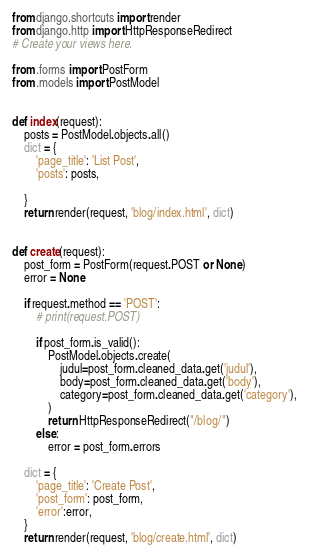<code> <loc_0><loc_0><loc_500><loc_500><_Python_>from django.shortcuts import render
from django.http import HttpResponseRedirect
# Create your views here.

from .forms import PostForm
from .models import PostModel


def index(request):
    posts = PostModel.objects.all()
    dict = {
        'page_title': 'List Post',
        'posts': posts,

    }
    return render(request, 'blog/index.html', dict)


def create(request):
    post_form = PostForm(request.POST or None)
    error = None

    if request.method == 'POST':
        # print(request.POST)

        if post_form.is_valid():
            PostModel.objects.create(
                judul=post_form.cleaned_data.get('judul'),
                body=post_form.cleaned_data.get('body'),
                category=post_form.cleaned_data.get('category'),
            )
            return HttpResponseRedirect("/blog/")
        else:
        	error = post_form.errors

    dict = {
        'page_title': 'Create Post',
        'post_form': post_form,
        'error':error,
    }
    return render(request, 'blog/create.html', dict)
</code> 